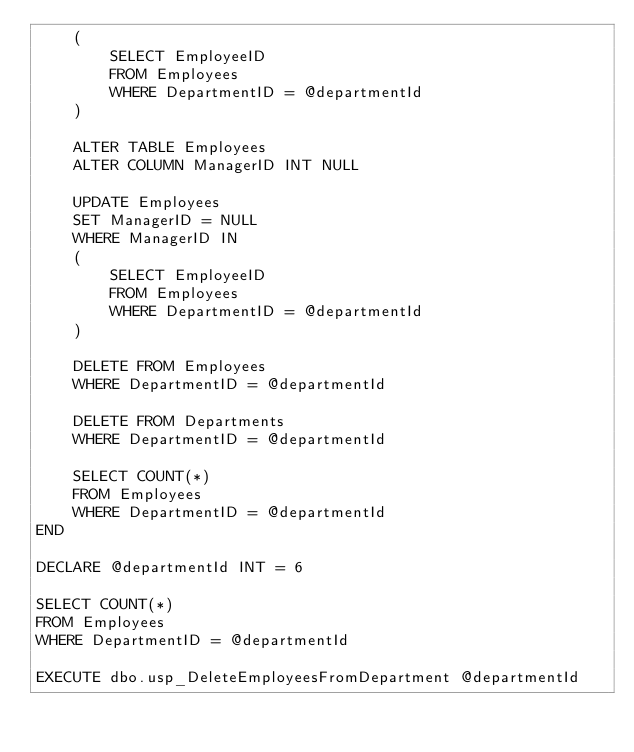Convert code to text. <code><loc_0><loc_0><loc_500><loc_500><_SQL_>	(
		SELECT EmployeeID
		FROM Employees
		WHERE DepartmentID = @departmentId
	)

	ALTER TABLE Employees
	ALTER COLUMN ManagerID INT NULL

	UPDATE Employees
	SET ManagerID = NULL
	WHERE ManagerID IN
	(
		SELECT EmployeeID
		FROM Employees
		WHERE DepartmentID = @departmentId
	)

	DELETE FROM Employees
	WHERE DepartmentID = @departmentId

	DELETE FROM Departments
	WHERE DepartmentID = @departmentId

	SELECT COUNT(*)
	FROM Employees
	WHERE DepartmentID = @departmentId
END

DECLARE @departmentId INT = 6

SELECT COUNT(*)
FROM Employees
WHERE DepartmentID = @departmentId

EXECUTE dbo.usp_DeleteEmployeesFromDepartment @departmentId
</code> 